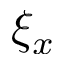<formula> <loc_0><loc_0><loc_500><loc_500>\xi _ { x }</formula> 